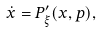<formula> <loc_0><loc_0><loc_500><loc_500>\dot { x } = P ^ { \prime } _ { \xi } ( x , p ) ,</formula> 